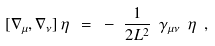Convert formula to latex. <formula><loc_0><loc_0><loc_500><loc_500>[ \nabla _ { \mu } , \nabla _ { \nu } ] \, \eta \ = \ - \ \frac { 1 } { 2 L ^ { 2 } } \ \gamma _ { \mu \nu } \ \eta \ ,</formula> 